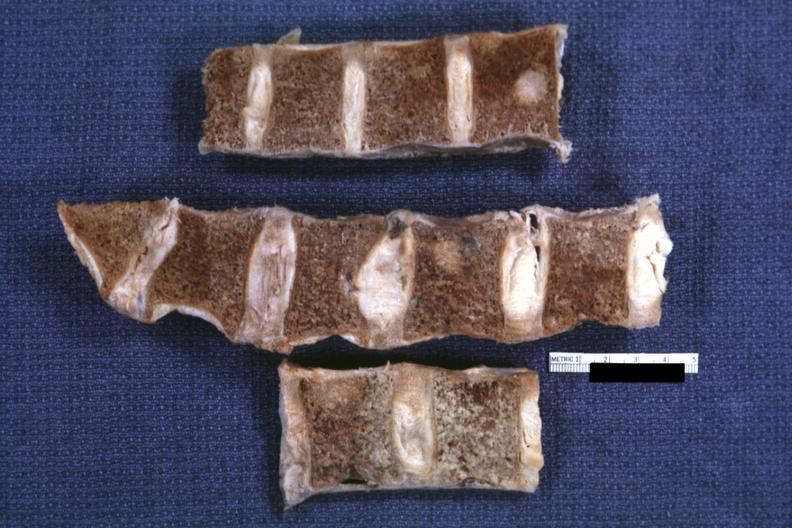what is present?
Answer the question using a single word or phrase. Joints 